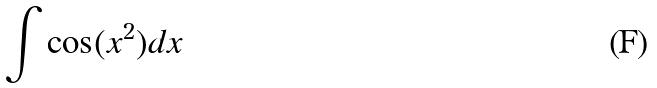Convert formula to latex. <formula><loc_0><loc_0><loc_500><loc_500>\int \cos ( x ^ { 2 } ) d x</formula> 